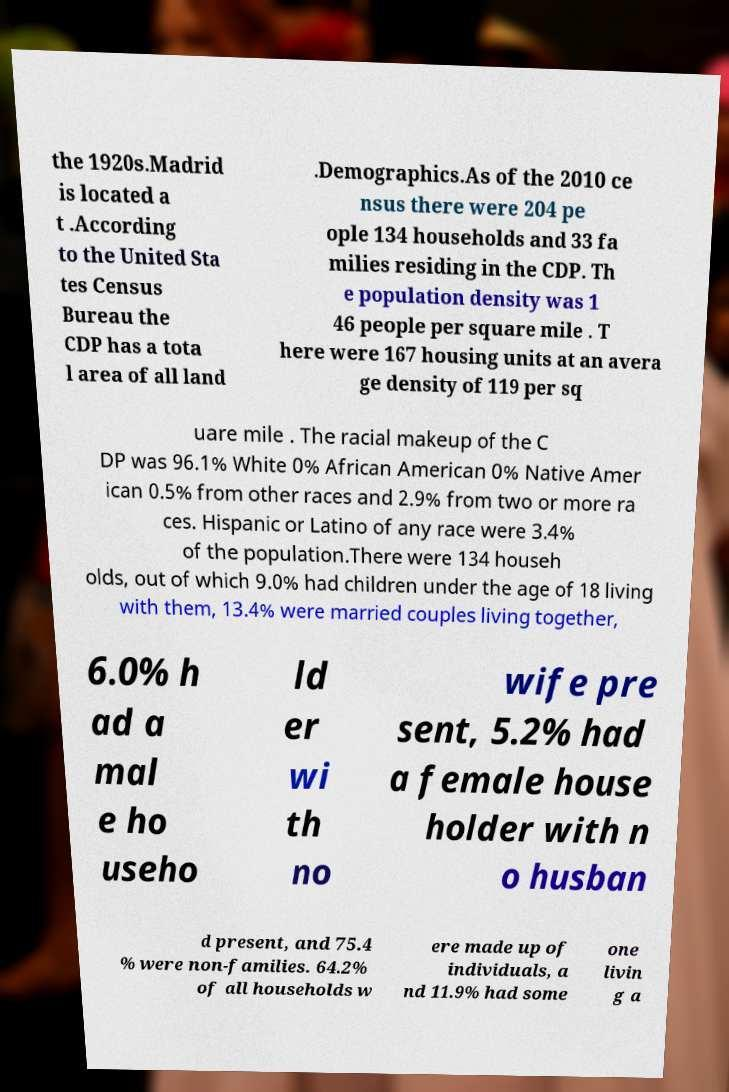Can you read and provide the text displayed in the image?This photo seems to have some interesting text. Can you extract and type it out for me? the 1920s.Madrid is located a t .According to the United Sta tes Census Bureau the CDP has a tota l area of all land .Demographics.As of the 2010 ce nsus there were 204 pe ople 134 households and 33 fa milies residing in the CDP. Th e population density was 1 46 people per square mile . T here were 167 housing units at an avera ge density of 119 per sq uare mile . The racial makeup of the C DP was 96.1% White 0% African American 0% Native Amer ican 0.5% from other races and 2.9% from two or more ra ces. Hispanic or Latino of any race were 3.4% of the population.There were 134 househ olds, out of which 9.0% had children under the age of 18 living with them, 13.4% were married couples living together, 6.0% h ad a mal e ho useho ld er wi th no wife pre sent, 5.2% had a female house holder with n o husban d present, and 75.4 % were non-families. 64.2% of all households w ere made up of individuals, a nd 11.9% had some one livin g a 